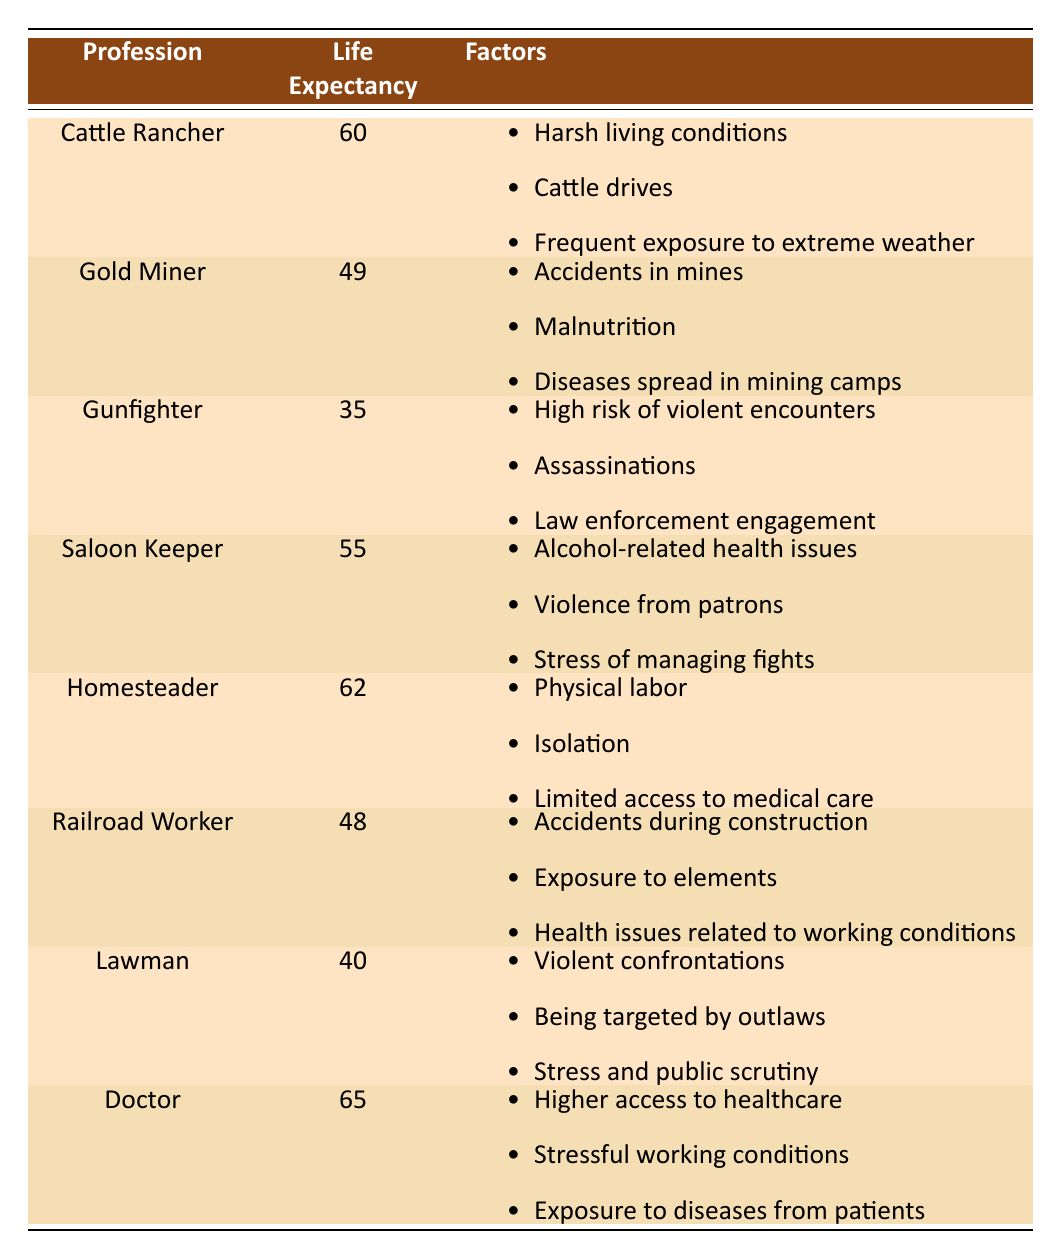What is the average life expectancy of a Cattle Rancher? According to the table, the average life expectancy of a Cattle Rancher is explicitly stated as 60 years.
Answer: 60 Which profession has the lowest life expectancy? The lowest life expectancy in the table is for the Gunfighter, which is 35 years.
Answer: Gunfighter What are two factors that contribute to the life expectancy of a Gold Miner? The table lists three factors for Gold Miners: accidents in mines, malnutrition, and diseases spread in mining camps. Two of these factors are accidents in mines and malnutrition.
Answer: Accidents in mines, malnutrition Is the average life expectancy of Homesteaders greater than that of Railroad Workers? The average life expectancy of Homesteaders is 62 years, while that of Railroad Workers is 48 years. Since 62 is greater than 48, the statement is true.
Answer: Yes What is the difference in life expectancy between Doctors and Lawmen? The life expectancy of Doctors is 65 years and that of Lawmen is 40 years. The difference is calculated as 65 - 40 = 25 years.
Answer: 25 What profession has an average life expectancy that is more than the average of 50 years? The Cattle Rancher (60), Homesteader (62), and Doctor (65) all have life expectancies above 50 years.
Answer: Cattle Rancher, Homesteader, Doctor Can we conclude that Saloon Keepers have a higher life expectancy than Railroad Workers? The average life expectancy of Saloon Keepers is 55 years and for Railroad Workers, it is 48 years. Since 55 is greater than 48, the conclusion is true.
Answer: Yes What is the average life expectancy of all the professions listed? To find the average, we sum the life expectancies: (60 + 49 + 35 + 55 + 62 + 48 + 40 + 65) = 414. There are 8 professions, so the average life expectancy is 414 / 8 = 51.75.
Answer: 51.75 Which profession experiences health issues related to working conditions? The table states that Railroad Workers experience health issues related to their working conditions.
Answer: Railroad Worker 